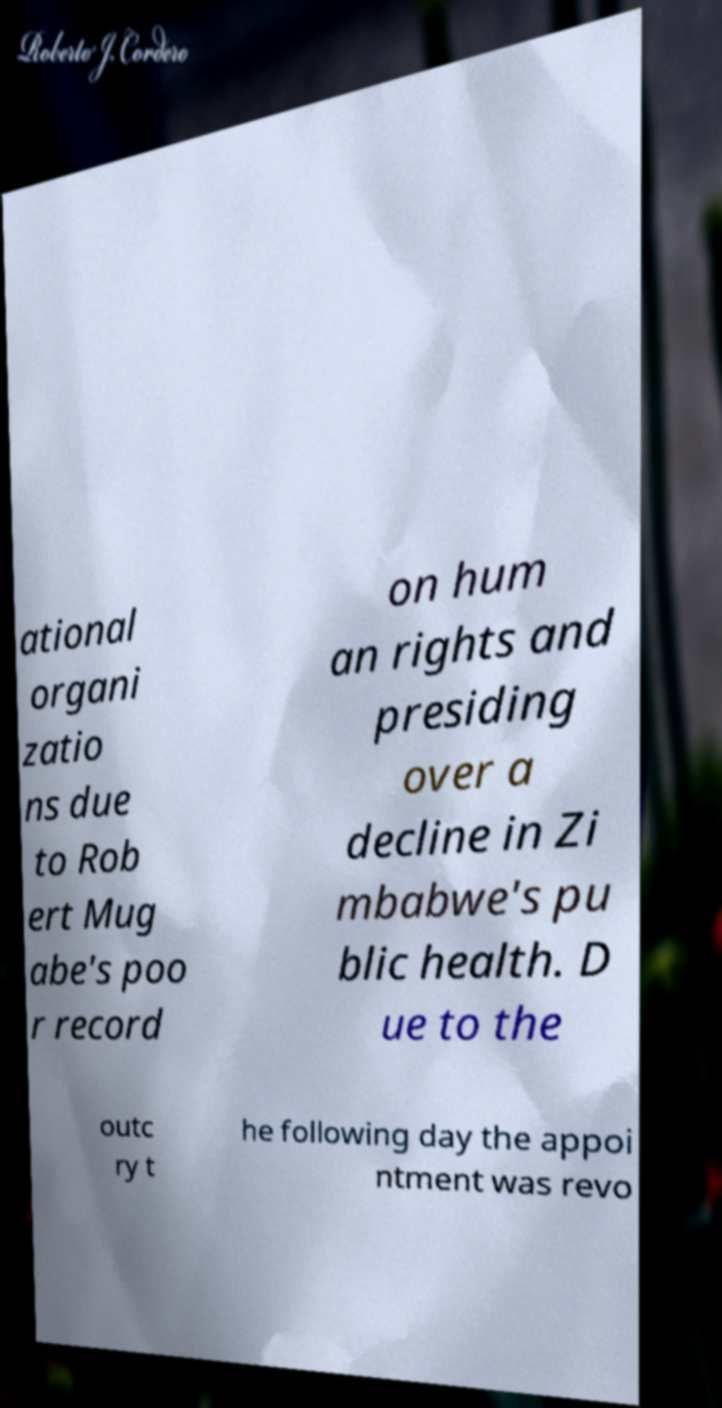Could you extract and type out the text from this image? ational organi zatio ns due to Rob ert Mug abe's poo r record on hum an rights and presiding over a decline in Zi mbabwe's pu blic health. D ue to the outc ry t he following day the appoi ntment was revo 